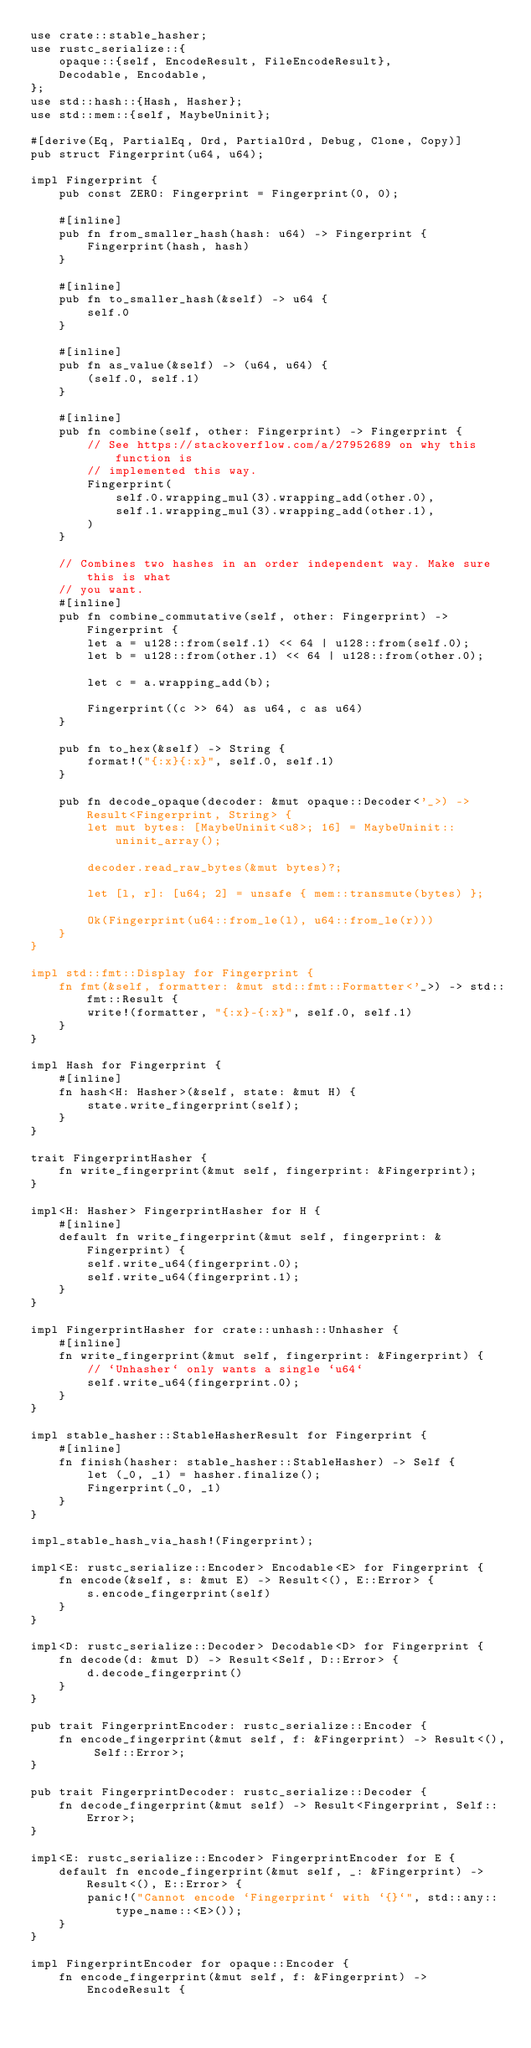Convert code to text. <code><loc_0><loc_0><loc_500><loc_500><_Rust_>use crate::stable_hasher;
use rustc_serialize::{
    opaque::{self, EncodeResult, FileEncodeResult},
    Decodable, Encodable,
};
use std::hash::{Hash, Hasher};
use std::mem::{self, MaybeUninit};

#[derive(Eq, PartialEq, Ord, PartialOrd, Debug, Clone, Copy)]
pub struct Fingerprint(u64, u64);

impl Fingerprint {
    pub const ZERO: Fingerprint = Fingerprint(0, 0);

    #[inline]
    pub fn from_smaller_hash(hash: u64) -> Fingerprint {
        Fingerprint(hash, hash)
    }

    #[inline]
    pub fn to_smaller_hash(&self) -> u64 {
        self.0
    }

    #[inline]
    pub fn as_value(&self) -> (u64, u64) {
        (self.0, self.1)
    }

    #[inline]
    pub fn combine(self, other: Fingerprint) -> Fingerprint {
        // See https://stackoverflow.com/a/27952689 on why this function is
        // implemented this way.
        Fingerprint(
            self.0.wrapping_mul(3).wrapping_add(other.0),
            self.1.wrapping_mul(3).wrapping_add(other.1),
        )
    }

    // Combines two hashes in an order independent way. Make sure this is what
    // you want.
    #[inline]
    pub fn combine_commutative(self, other: Fingerprint) -> Fingerprint {
        let a = u128::from(self.1) << 64 | u128::from(self.0);
        let b = u128::from(other.1) << 64 | u128::from(other.0);

        let c = a.wrapping_add(b);

        Fingerprint((c >> 64) as u64, c as u64)
    }

    pub fn to_hex(&self) -> String {
        format!("{:x}{:x}", self.0, self.1)
    }

    pub fn decode_opaque(decoder: &mut opaque::Decoder<'_>) -> Result<Fingerprint, String> {
        let mut bytes: [MaybeUninit<u8>; 16] = MaybeUninit::uninit_array();

        decoder.read_raw_bytes(&mut bytes)?;

        let [l, r]: [u64; 2] = unsafe { mem::transmute(bytes) };

        Ok(Fingerprint(u64::from_le(l), u64::from_le(r)))
    }
}

impl std::fmt::Display for Fingerprint {
    fn fmt(&self, formatter: &mut std::fmt::Formatter<'_>) -> std::fmt::Result {
        write!(formatter, "{:x}-{:x}", self.0, self.1)
    }
}

impl Hash for Fingerprint {
    #[inline]
    fn hash<H: Hasher>(&self, state: &mut H) {
        state.write_fingerprint(self);
    }
}

trait FingerprintHasher {
    fn write_fingerprint(&mut self, fingerprint: &Fingerprint);
}

impl<H: Hasher> FingerprintHasher for H {
    #[inline]
    default fn write_fingerprint(&mut self, fingerprint: &Fingerprint) {
        self.write_u64(fingerprint.0);
        self.write_u64(fingerprint.1);
    }
}

impl FingerprintHasher for crate::unhash::Unhasher {
    #[inline]
    fn write_fingerprint(&mut self, fingerprint: &Fingerprint) {
        // `Unhasher` only wants a single `u64`
        self.write_u64(fingerprint.0);
    }
}

impl stable_hasher::StableHasherResult for Fingerprint {
    #[inline]
    fn finish(hasher: stable_hasher::StableHasher) -> Self {
        let (_0, _1) = hasher.finalize();
        Fingerprint(_0, _1)
    }
}

impl_stable_hash_via_hash!(Fingerprint);

impl<E: rustc_serialize::Encoder> Encodable<E> for Fingerprint {
    fn encode(&self, s: &mut E) -> Result<(), E::Error> {
        s.encode_fingerprint(self)
    }
}

impl<D: rustc_serialize::Decoder> Decodable<D> for Fingerprint {
    fn decode(d: &mut D) -> Result<Self, D::Error> {
        d.decode_fingerprint()
    }
}

pub trait FingerprintEncoder: rustc_serialize::Encoder {
    fn encode_fingerprint(&mut self, f: &Fingerprint) -> Result<(), Self::Error>;
}

pub trait FingerprintDecoder: rustc_serialize::Decoder {
    fn decode_fingerprint(&mut self) -> Result<Fingerprint, Self::Error>;
}

impl<E: rustc_serialize::Encoder> FingerprintEncoder for E {
    default fn encode_fingerprint(&mut self, _: &Fingerprint) -> Result<(), E::Error> {
        panic!("Cannot encode `Fingerprint` with `{}`", std::any::type_name::<E>());
    }
}

impl FingerprintEncoder for opaque::Encoder {
    fn encode_fingerprint(&mut self, f: &Fingerprint) -> EncodeResult {</code> 